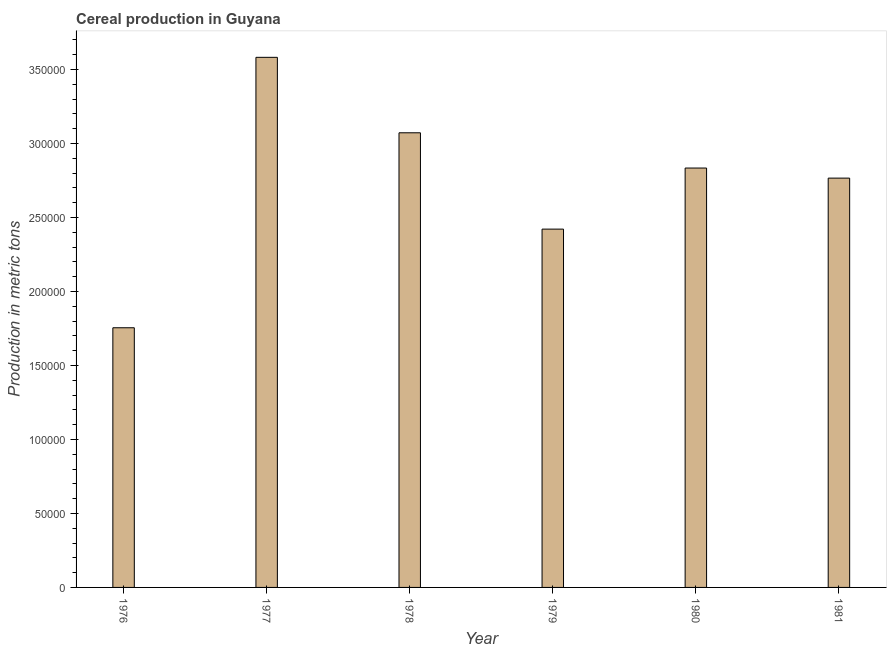Does the graph contain any zero values?
Keep it short and to the point. No. What is the title of the graph?
Keep it short and to the point. Cereal production in Guyana. What is the label or title of the Y-axis?
Provide a short and direct response. Production in metric tons. What is the cereal production in 1979?
Give a very brief answer. 2.42e+05. Across all years, what is the maximum cereal production?
Your answer should be very brief. 3.58e+05. Across all years, what is the minimum cereal production?
Provide a short and direct response. 1.75e+05. In which year was the cereal production maximum?
Provide a succinct answer. 1977. In which year was the cereal production minimum?
Provide a short and direct response. 1976. What is the sum of the cereal production?
Keep it short and to the point. 1.64e+06. What is the difference between the cereal production in 1978 and 1979?
Your answer should be compact. 6.51e+04. What is the average cereal production per year?
Offer a terse response. 2.74e+05. What is the median cereal production?
Keep it short and to the point. 2.80e+05. Do a majority of the years between 1976 and 1981 (inclusive) have cereal production greater than 180000 metric tons?
Keep it short and to the point. Yes. What is the ratio of the cereal production in 1979 to that in 1981?
Provide a short and direct response. 0.88. Is the difference between the cereal production in 1978 and 1981 greater than the difference between any two years?
Your answer should be very brief. No. What is the difference between the highest and the second highest cereal production?
Your answer should be very brief. 5.10e+04. What is the difference between the highest and the lowest cereal production?
Keep it short and to the point. 1.83e+05. How many bars are there?
Make the answer very short. 6. Are all the bars in the graph horizontal?
Your response must be concise. No. How many years are there in the graph?
Ensure brevity in your answer.  6. What is the difference between two consecutive major ticks on the Y-axis?
Your response must be concise. 5.00e+04. What is the Production in metric tons of 1976?
Offer a terse response. 1.75e+05. What is the Production in metric tons in 1977?
Make the answer very short. 3.58e+05. What is the Production in metric tons in 1978?
Offer a terse response. 3.07e+05. What is the Production in metric tons in 1979?
Your response must be concise. 2.42e+05. What is the Production in metric tons of 1980?
Offer a terse response. 2.83e+05. What is the Production in metric tons in 1981?
Provide a succinct answer. 2.77e+05. What is the difference between the Production in metric tons in 1976 and 1977?
Your response must be concise. -1.83e+05. What is the difference between the Production in metric tons in 1976 and 1978?
Keep it short and to the point. -1.32e+05. What is the difference between the Production in metric tons in 1976 and 1979?
Provide a succinct answer. -6.67e+04. What is the difference between the Production in metric tons in 1976 and 1980?
Give a very brief answer. -1.08e+05. What is the difference between the Production in metric tons in 1976 and 1981?
Ensure brevity in your answer.  -1.01e+05. What is the difference between the Production in metric tons in 1977 and 1978?
Offer a very short reply. 5.10e+04. What is the difference between the Production in metric tons in 1977 and 1979?
Make the answer very short. 1.16e+05. What is the difference between the Production in metric tons in 1977 and 1980?
Keep it short and to the point. 7.48e+04. What is the difference between the Production in metric tons in 1977 and 1981?
Your answer should be very brief. 8.16e+04. What is the difference between the Production in metric tons in 1978 and 1979?
Make the answer very short. 6.51e+04. What is the difference between the Production in metric tons in 1978 and 1980?
Keep it short and to the point. 2.38e+04. What is the difference between the Production in metric tons in 1978 and 1981?
Ensure brevity in your answer.  3.06e+04. What is the difference between the Production in metric tons in 1979 and 1980?
Your answer should be very brief. -4.13e+04. What is the difference between the Production in metric tons in 1979 and 1981?
Your answer should be very brief. -3.45e+04. What is the difference between the Production in metric tons in 1980 and 1981?
Your response must be concise. 6804. What is the ratio of the Production in metric tons in 1976 to that in 1977?
Offer a terse response. 0.49. What is the ratio of the Production in metric tons in 1976 to that in 1978?
Provide a short and direct response. 0.57. What is the ratio of the Production in metric tons in 1976 to that in 1979?
Offer a very short reply. 0.72. What is the ratio of the Production in metric tons in 1976 to that in 1980?
Ensure brevity in your answer.  0.62. What is the ratio of the Production in metric tons in 1976 to that in 1981?
Offer a terse response. 0.63. What is the ratio of the Production in metric tons in 1977 to that in 1978?
Provide a short and direct response. 1.17. What is the ratio of the Production in metric tons in 1977 to that in 1979?
Offer a terse response. 1.48. What is the ratio of the Production in metric tons in 1977 to that in 1980?
Your answer should be very brief. 1.26. What is the ratio of the Production in metric tons in 1977 to that in 1981?
Offer a very short reply. 1.29. What is the ratio of the Production in metric tons in 1978 to that in 1979?
Your answer should be very brief. 1.27. What is the ratio of the Production in metric tons in 1978 to that in 1980?
Keep it short and to the point. 1.08. What is the ratio of the Production in metric tons in 1978 to that in 1981?
Your answer should be compact. 1.11. What is the ratio of the Production in metric tons in 1979 to that in 1980?
Keep it short and to the point. 0.85. What is the ratio of the Production in metric tons in 1980 to that in 1981?
Your response must be concise. 1.02. 